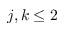<formula> <loc_0><loc_0><loc_500><loc_500>j , k \leq 2</formula> 